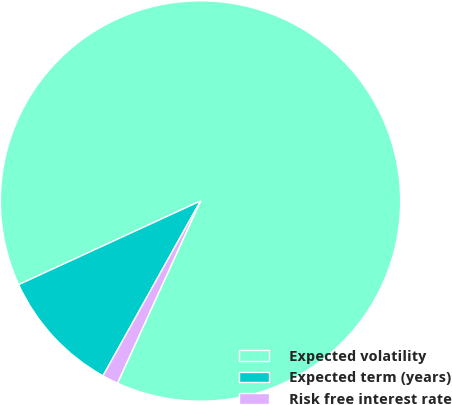Convert chart to OTSL. <chart><loc_0><loc_0><loc_500><loc_500><pie_chart><fcel>Expected volatility<fcel>Expected term (years)<fcel>Risk free interest rate<nl><fcel>88.67%<fcel>10.04%<fcel>1.29%<nl></chart> 